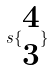Convert formula to latex. <formula><loc_0><loc_0><loc_500><loc_500>s \{ \begin{matrix} 4 \\ 3 \end{matrix} \}</formula> 